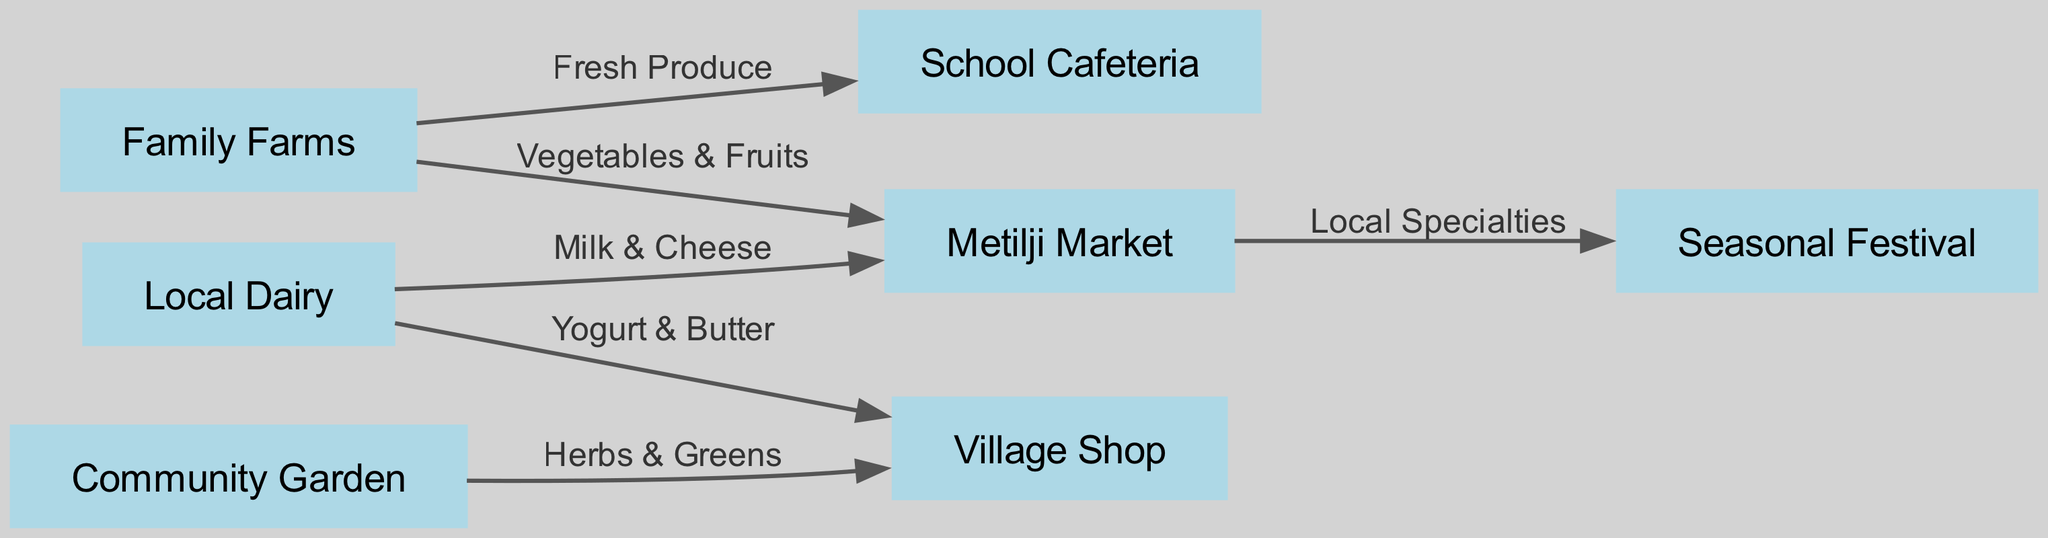What's the total number of nodes in the diagram? The diagram lists the following nodes: Family Farms, Community Garden, Local Dairy, Metilji Market, School Cafeteria, Village Shop, and Seasonal Festival. Counting each of these nodes gives us a total of 7.
Answer: 7 What type of produce comes from Family Farms to Metilji Market? The diagram shows an edge labeled "Vegetables & Fruits" that connects Family Farms to Metilji Market. This indicates that Family Farms supply Vegetables and Fruits to Metilji Market.
Answer: Vegetables & Fruits Which market receives products from Local Dairy? There are two outgoing edges from Local Dairy: one to Metilji Market labeled "Milk & Cheese" and another to Village Shop labeled "Yogurt & Butter." This means that Local Dairy sends products to both Metilji Market and Village Shop.
Answer: Metilji Market and Village Shop How many different paths lead from Family Farms in the diagram? Family Farms connects to Metilji Market (Vegetables & Fruits) and School Cafeteria (Fresh Produce). These two outgoing edges constitute two paths from Family Farms.
Answer: 2 What is the role of Seasonal Festival in the diagram? The Seasonal Festival has an incoming edge from Metilji Market that is labeled "Local Specialties." This suggests that the festival showcases or includes local specialty products sourced from the market.
Answer: Showcases Local Specialties If all locally produced goods go to Village Shop, what are the sources? The sources are Community Garden (Herbs & Greens) and Local Dairy (Yogurt & Butter) as indicated by the edges connecting to Village Shop. Both nodes supply products specifically to Village Shop.
Answer: Community Garden and Local Dairy Which node is directly linked to School Cafeteria? The diagram indicates that Family Farms supplies "Fresh Produce" directly to School Cafeteria, showing a direct connection between these two nodes.
Answer: Family Farms What types of products flow from Local Dairy to Village Shop? The edge from Local Dairy to Village Shop is labeled "Yogurt & Butter," indicating that these types of dairy products flow directly to the Village Shop.
Answer: Yogurt & Butter 